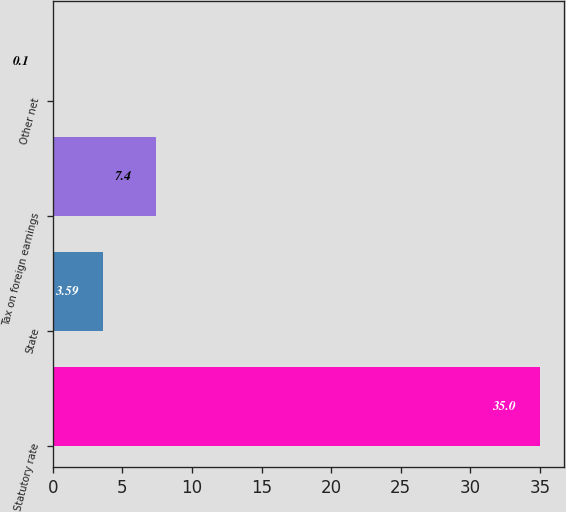<chart> <loc_0><loc_0><loc_500><loc_500><bar_chart><fcel>Statutory rate<fcel>State<fcel>Tax on foreign earnings<fcel>Other net<nl><fcel>35<fcel>3.59<fcel>7.4<fcel>0.1<nl></chart> 